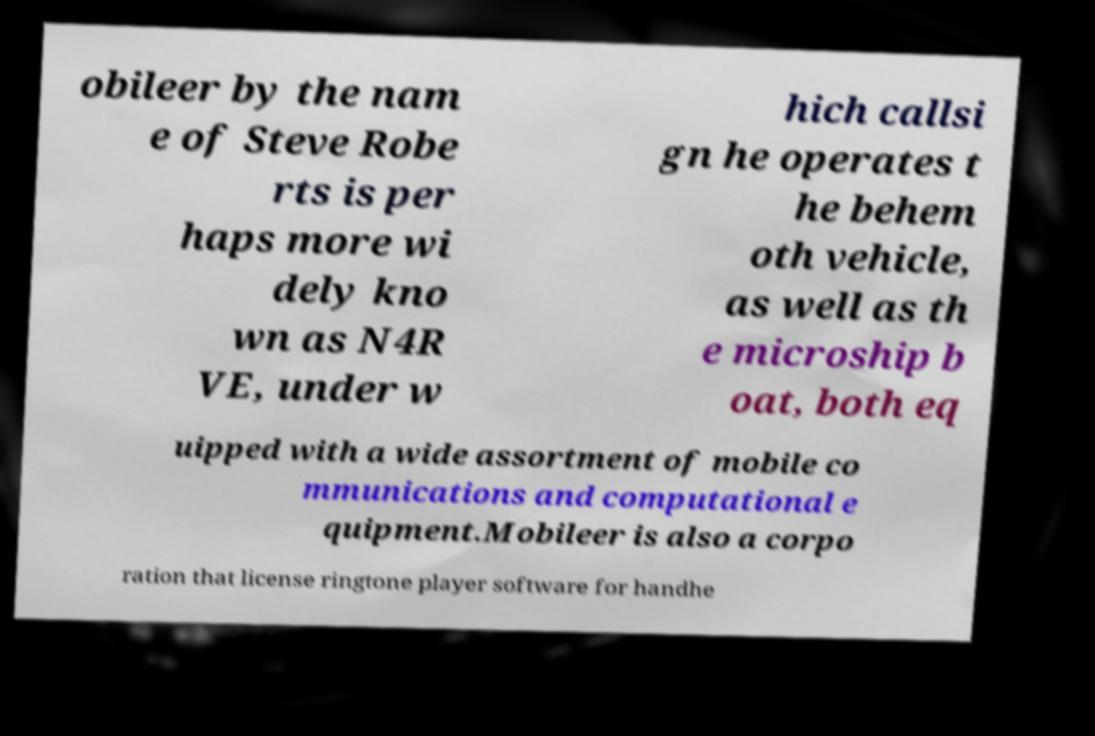For documentation purposes, I need the text within this image transcribed. Could you provide that? obileer by the nam e of Steve Robe rts is per haps more wi dely kno wn as N4R VE, under w hich callsi gn he operates t he behem oth vehicle, as well as th e microship b oat, both eq uipped with a wide assortment of mobile co mmunications and computational e quipment.Mobileer is also a corpo ration that license ringtone player software for handhe 